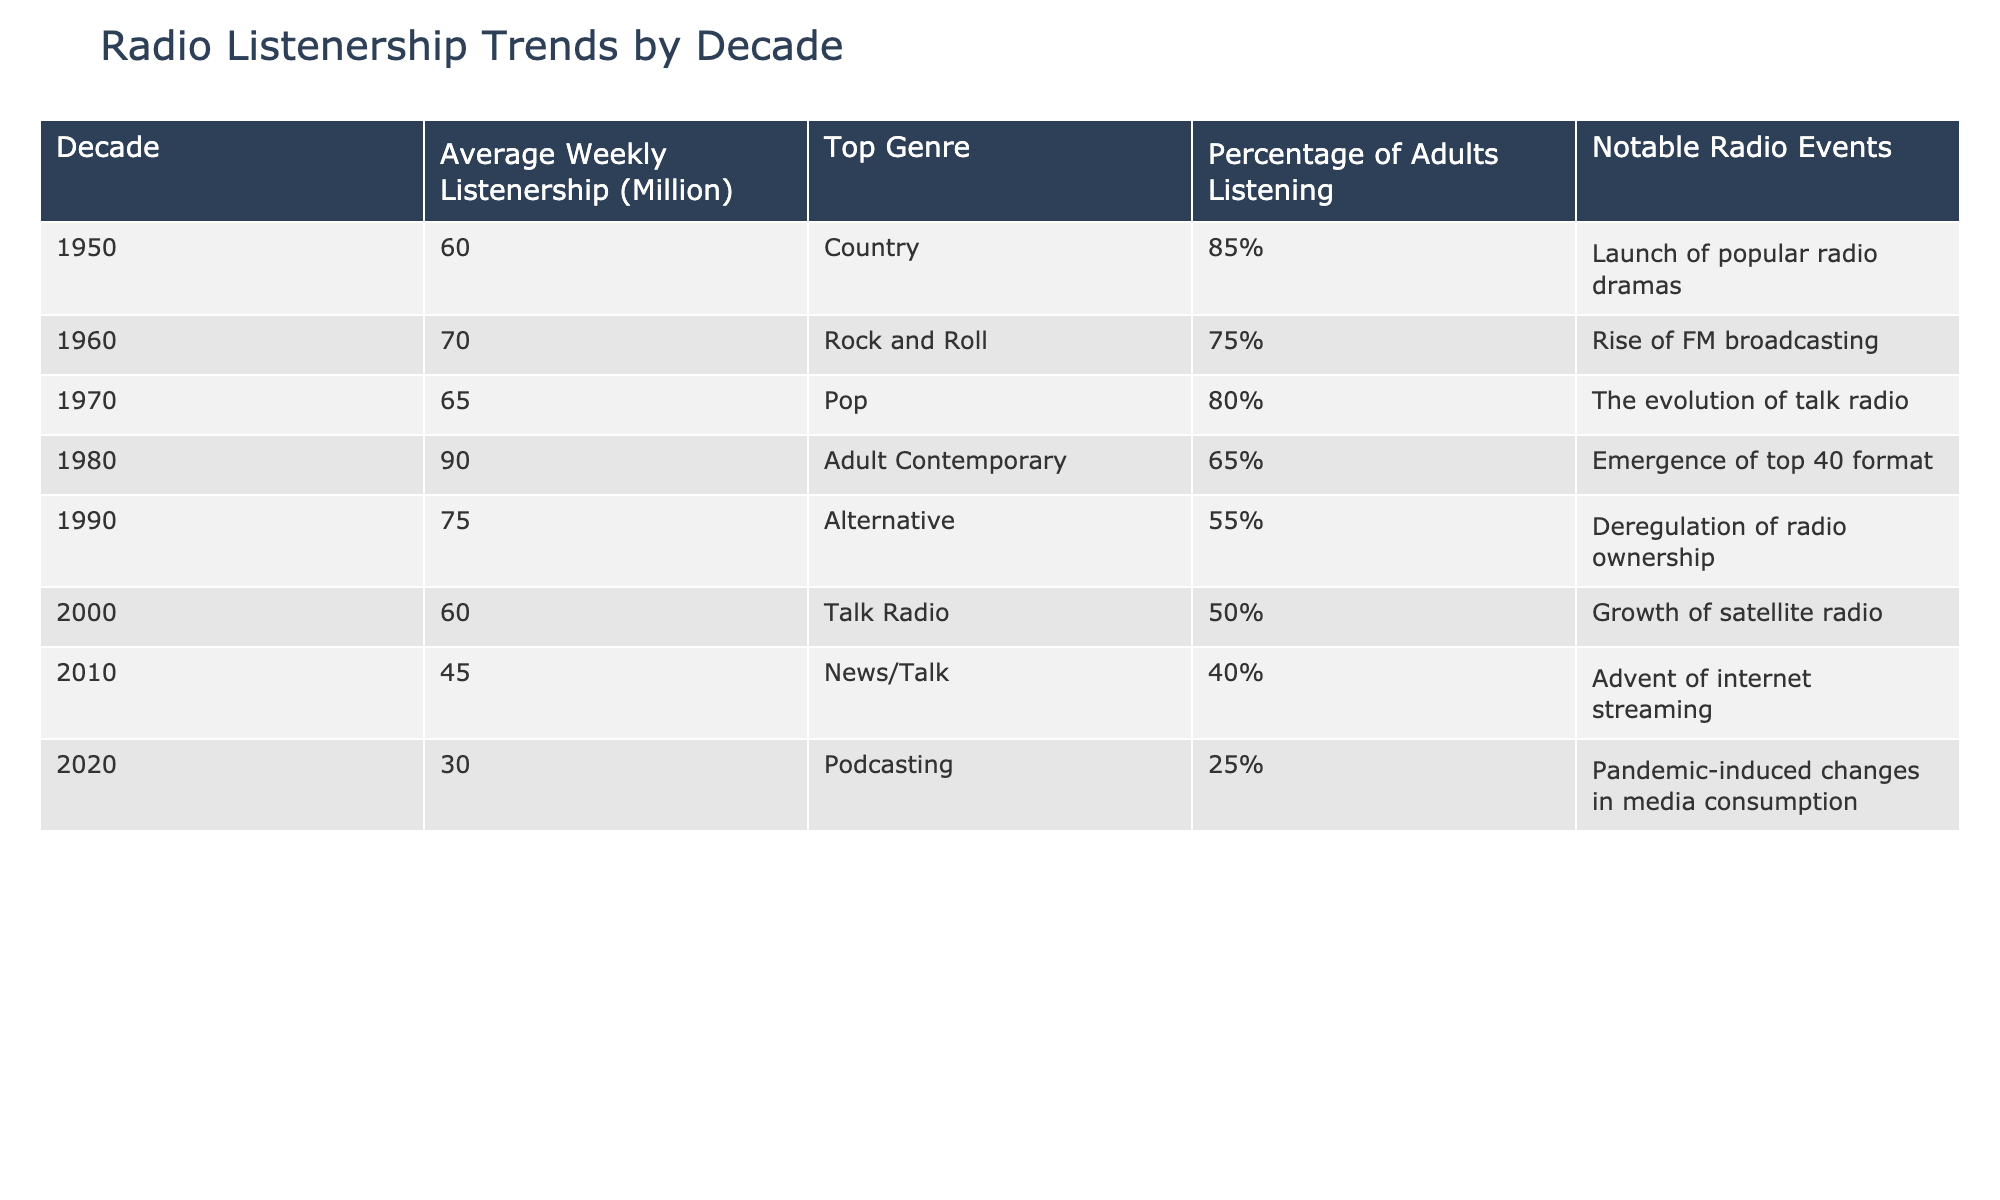What was the average weekly listenership in the 1980s? In the 1980s, we look specifically at the data from 1980 to 1989. The average weekly listenership in 1980 is 90 million. Therefore, the average weekly listenership for the decade of the 1980s is 90 million.
Answer: 90 million Which decade saw the highest percentage of adults listening to the radio? The table indicates the percentage of adults listening in each decade. The highest value is 85% during the 1950s. Thus, the decade with the highest percentage of adults listening is the 1950s.
Answer: 1950s Is it true that radio listenership decreased from the 1960s to the 1970s? From the table, weekly listenership in the 1960s was 70 million, while in the 1970s it was 65 million. Therefore, it is true that listenership decreased from the 1960s to the 1970s.
Answer: Yes What was the average listenership from 1990 to 2020? We need to calculate the average weekly listenership for the years 1990 (75), 2000 (60), 2010 (45), and 2020 (30). Adding these gives us 75 + 60 + 45 + 30 = 210. There are four data points, so the average is 210/4 = 52.5 million.
Answer: 52.5 million Which genre had the lowest percentage of adults listening in 2020? Looking at the table, in 2020, the percentage of adults listening is lowest for Podcasting at 25%. Thus, Podcasting is the genre with the lowest percentage.
Answer: Podcasting What notable radio event occurred in 1990? Referring to the notable radio events column for the year 1990, it states "Deregulation of radio ownership." Therefore, the notable event during that year was deregulation.
Answer: Deregulation of radio ownership Which decades saw an increase in listenership compared to the previous decade? Examining the average weekly listenership: from the 1950s to the 1960s, listenership increased from 60 to 70 million, from the 1960s to the 1970s it decreased to 65 million, and then from the 1970s to 1980s it increased again to 90 million. The only decades that saw an increase compared to the prior decade are the 1950s to 1960s and the 1970s to 1980s.
Answer: 1950s to 1960s and 1970s to 1980s What was the change in weekly listenership from the 2010s to the 2020s? Weekly listenership in 2010 was 45 million and decreased to 30 million in 2020. The change is calculated as 30 - 45 = -15 million, indicating a drop.
Answer: Decreased by 15 million 